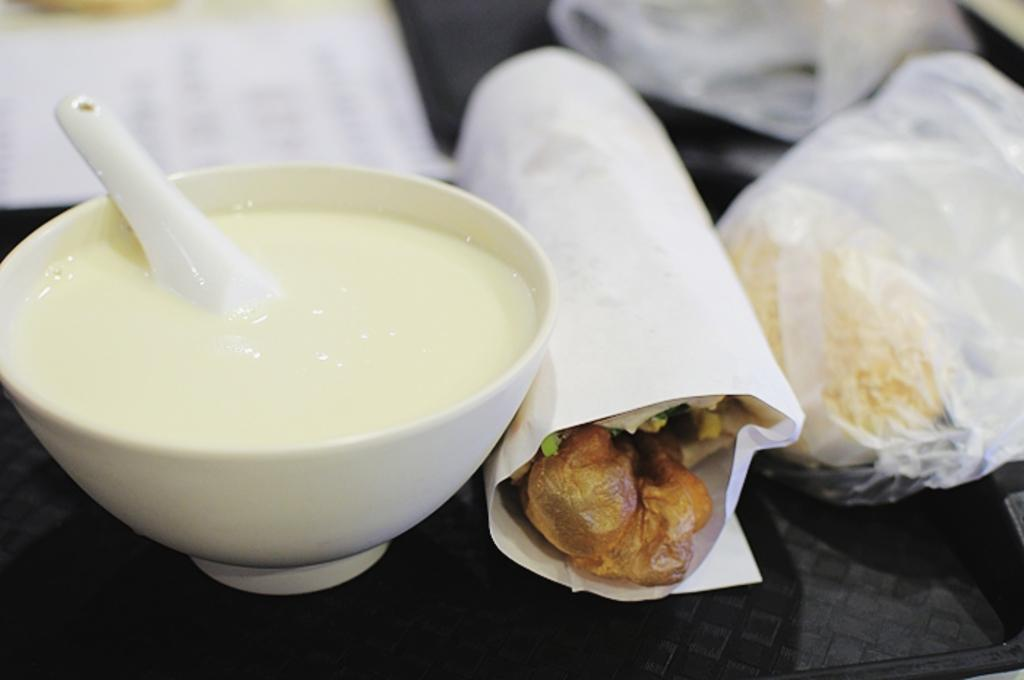What types of items can be seen in the image? There are food items in the image. How are the food items arranged or presented? The food items are on a black tray. What type of sail is visible in the image? There is no sail present in the image; it features food items on a black tray. What caption is written on the food items in the image? There is no caption written on the food items in the image. 